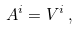<formula> <loc_0><loc_0><loc_500><loc_500>A ^ { i } = V ^ { i } \, ,</formula> 